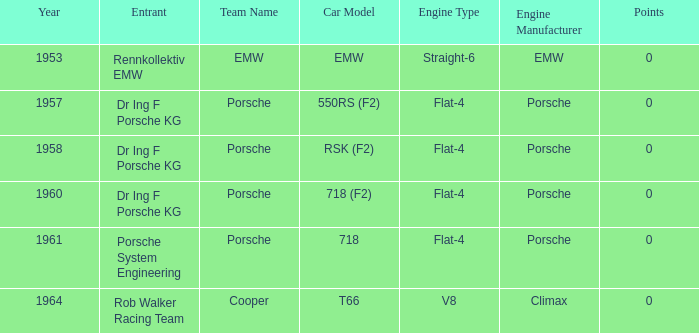What chassis did the porsche flat-4 use before 1958? Porsche 550RS (F2). 